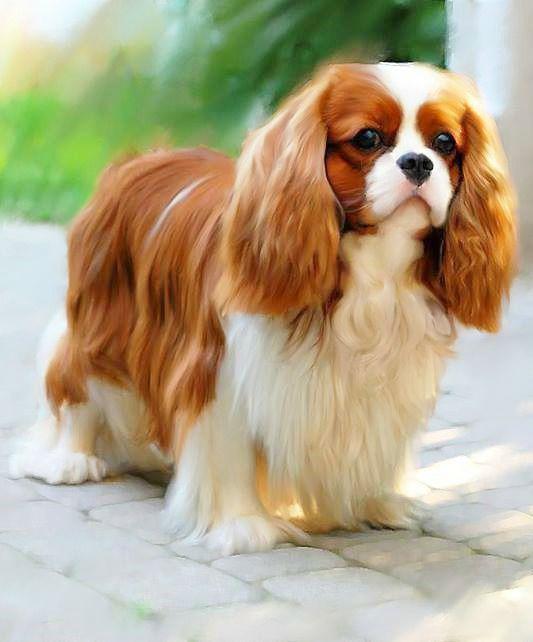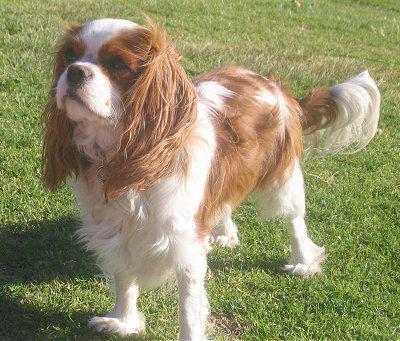The first image is the image on the left, the second image is the image on the right. Analyze the images presented: Is the assertion "An image shows just one dog on green grass." valid? Answer yes or no. Yes. The first image is the image on the left, the second image is the image on the right. Evaluate the accuracy of this statement regarding the images: "There is a single dog on grass in one of the images.". Is it true? Answer yes or no. Yes. The first image is the image on the left, the second image is the image on the right. Considering the images on both sides, is "An image shows one spaniel posed on green grass." valid? Answer yes or no. Yes. The first image is the image on the left, the second image is the image on the right. For the images shown, is this caption "One of the images shows one dog on grass." true? Answer yes or no. Yes. 